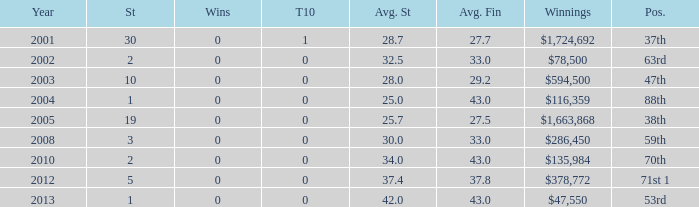How many wins for average start less than 25? 0.0. 